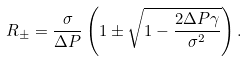Convert formula to latex. <formula><loc_0><loc_0><loc_500><loc_500>R _ { \pm } = \frac { \sigma } { \Delta P } \left ( 1 \pm \sqrt { 1 - \frac { 2 \Delta P \gamma } { \sigma ^ { 2 } } } \right ) .</formula> 